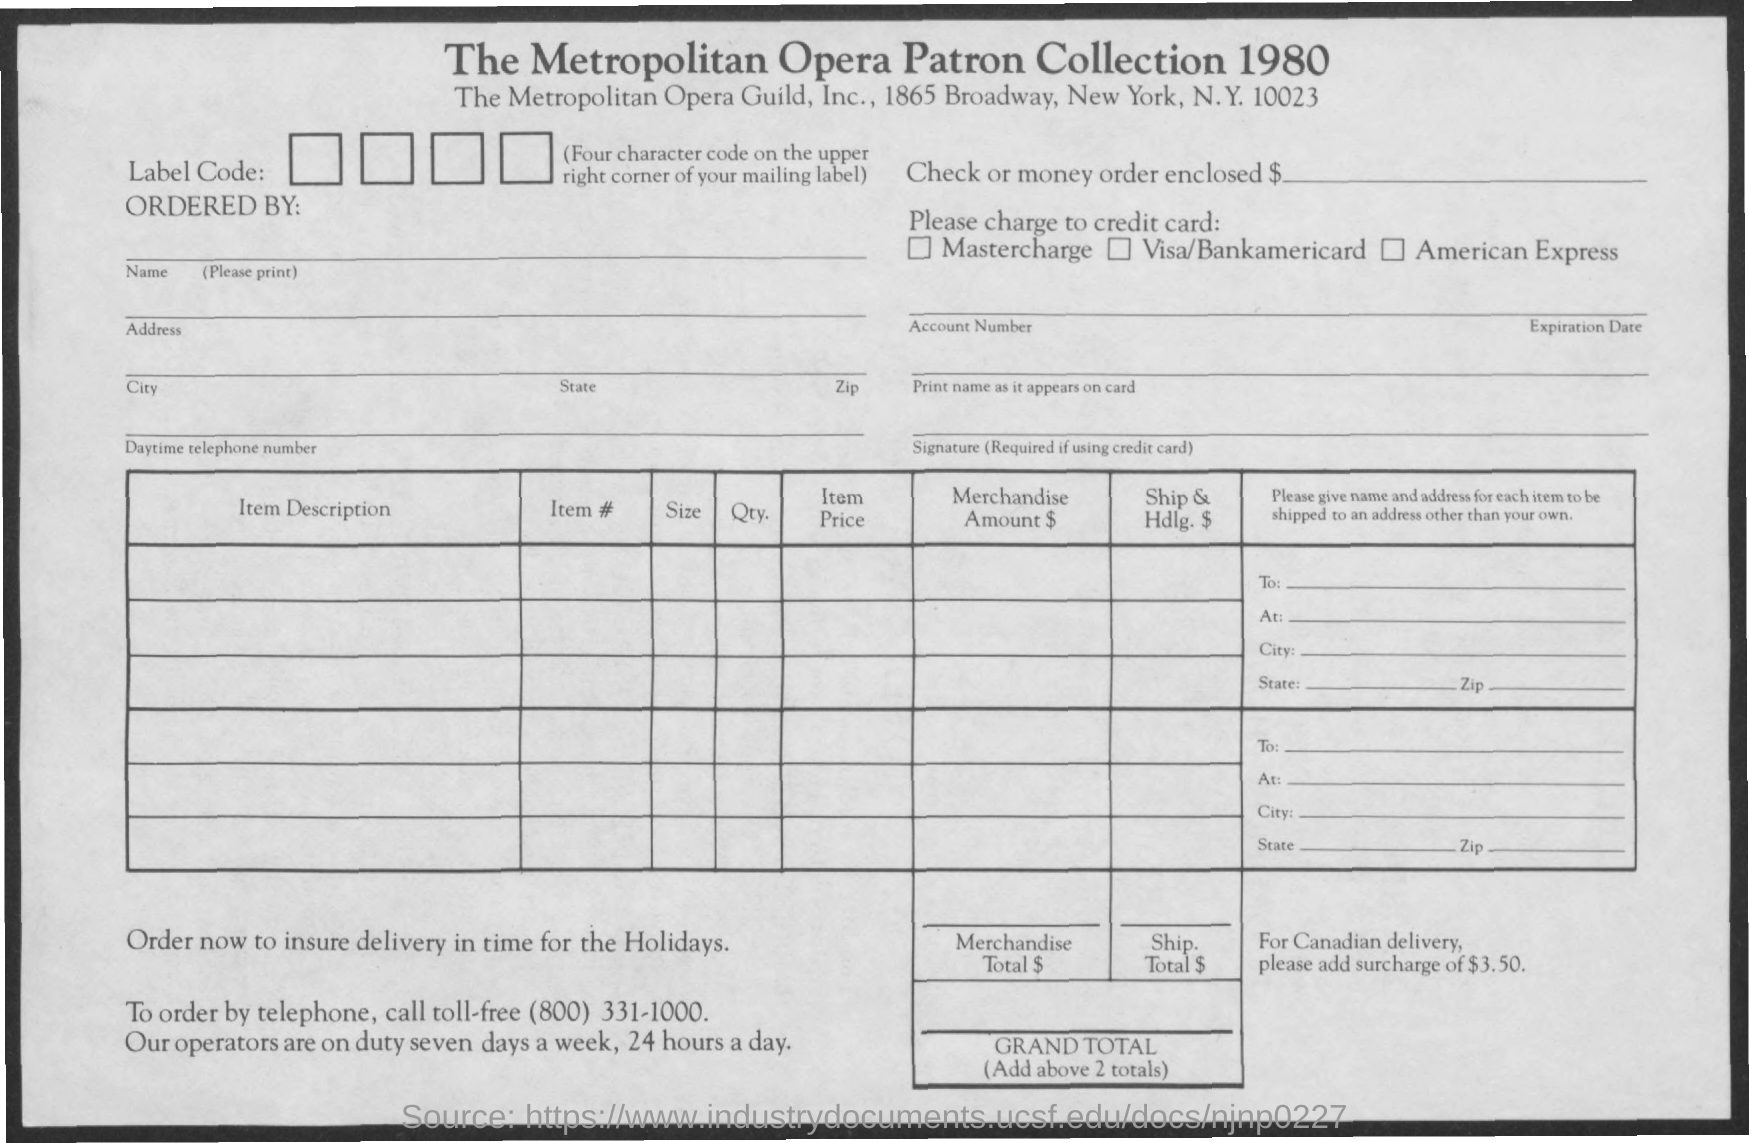What is the city name mentioned
Your response must be concise. New york. 